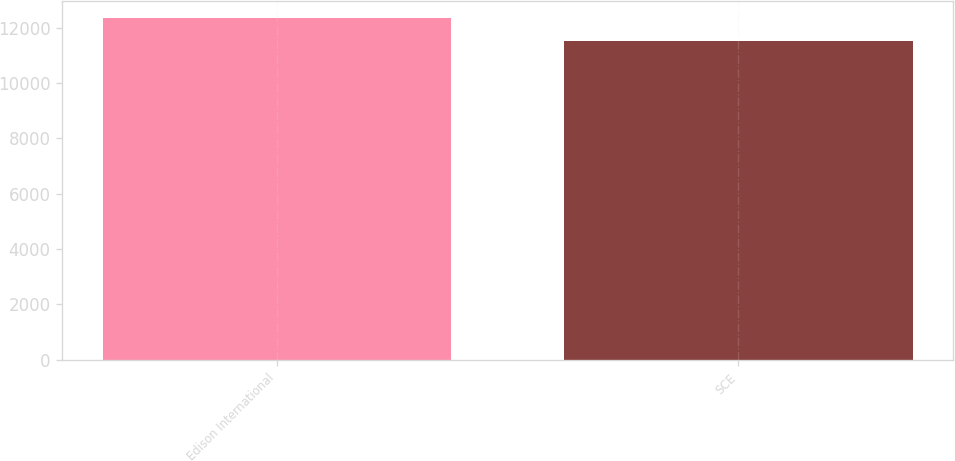Convert chart to OTSL. <chart><loc_0><loc_0><loc_500><loc_500><bar_chart><fcel>Edison International<fcel>SCE<nl><fcel>12368<fcel>11539<nl></chart> 